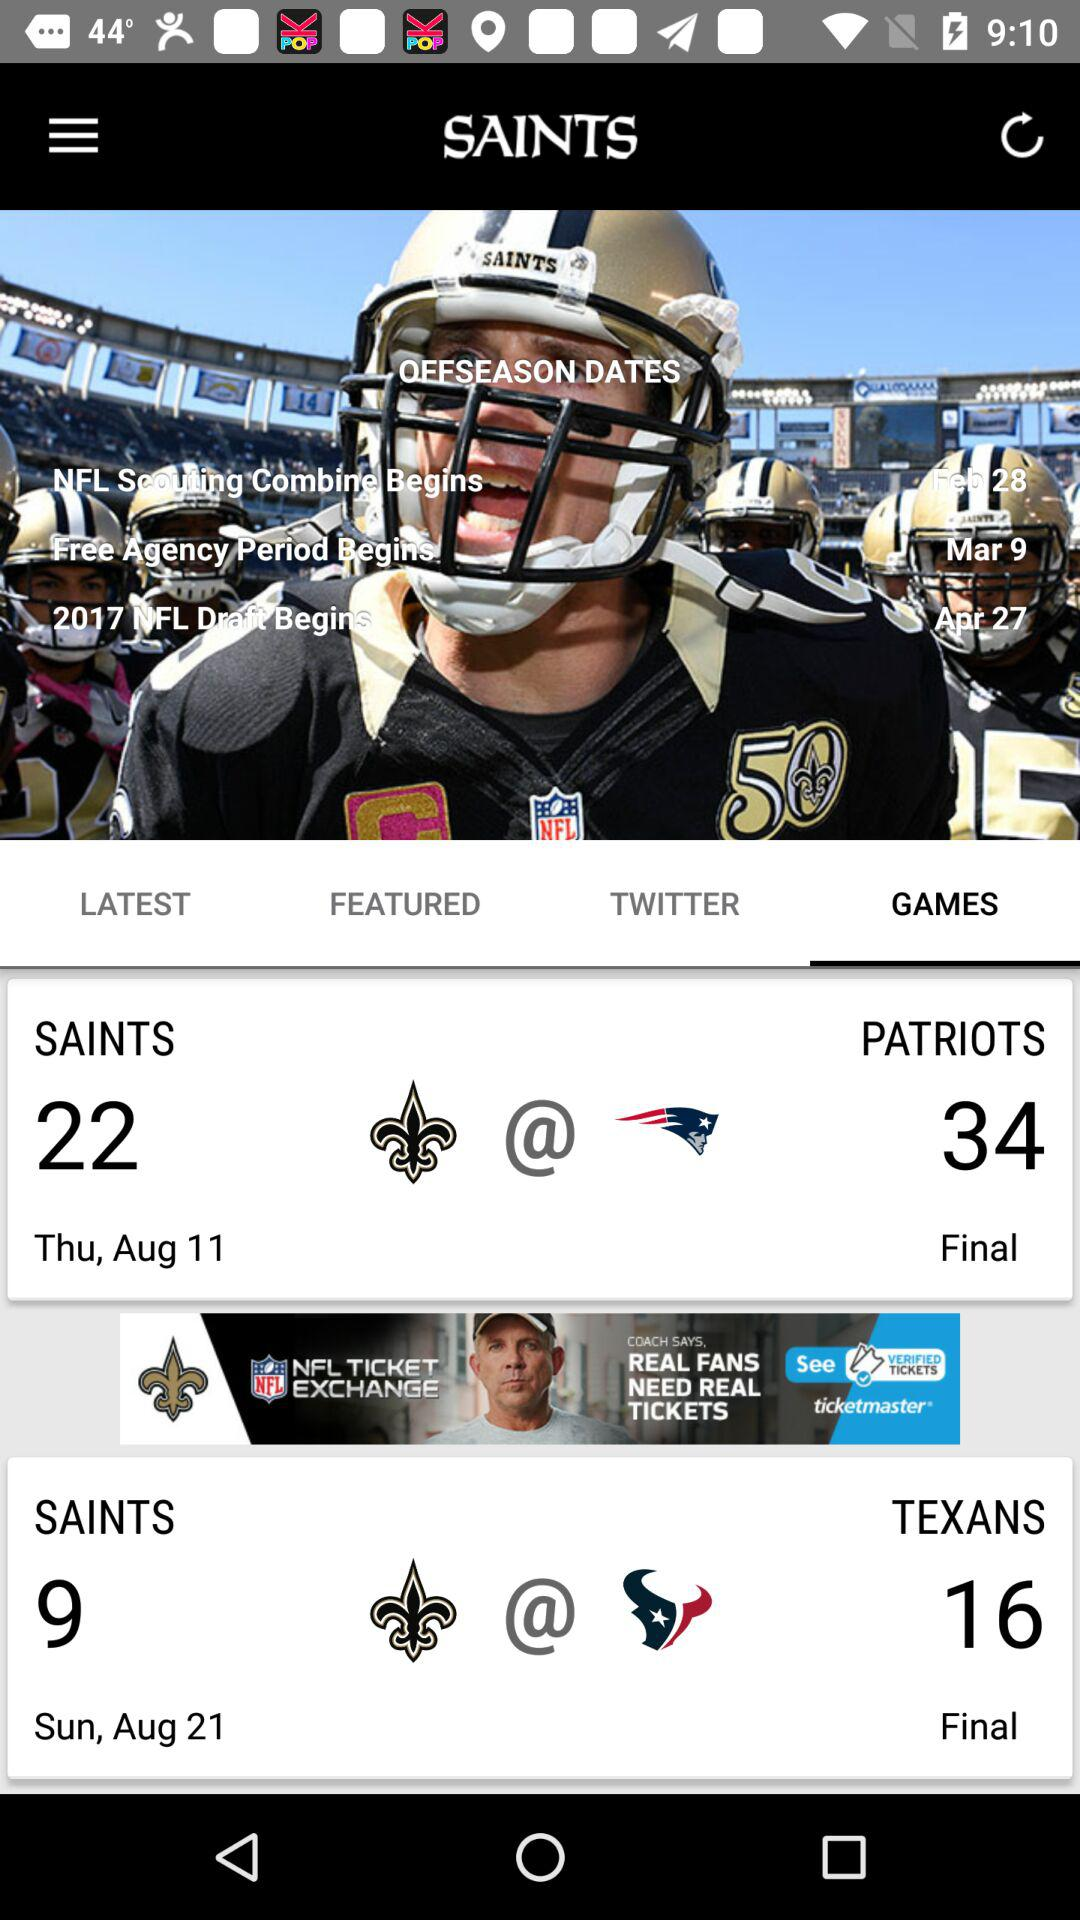How many more points does the Patriots have than the Saints?
Answer the question using a single word or phrase. 12 